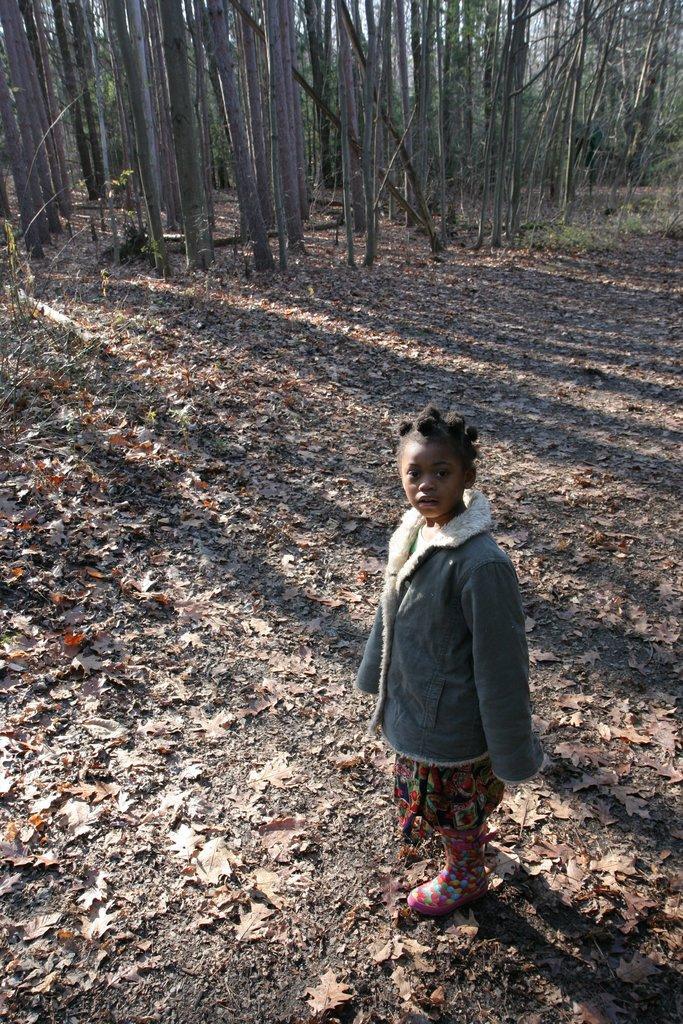Please provide a concise description of this image. In front of the picture, the girl in the grey jacket is standing and she is looking at the camera. At the bottom, we see dry leaves and twigs. There are trees in the background. 